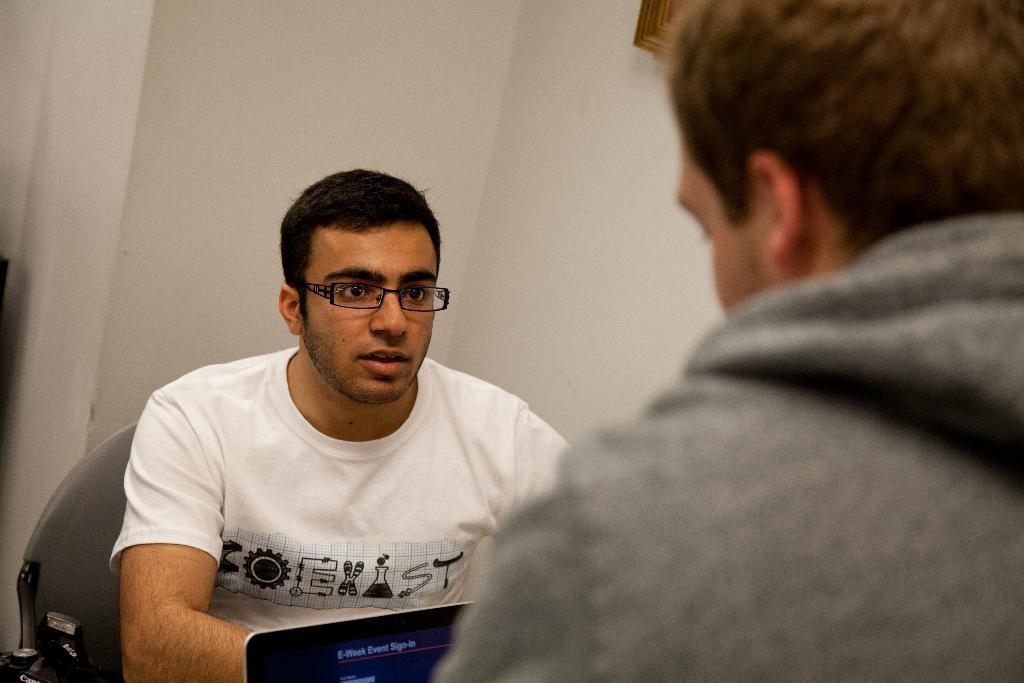In one or two sentences, can you explain what this image depicts? In this image I can see a person on the right. There is a laptop and a person is sitting, wearing a white t shirt and spectacles. There is a white wall at the back and there is a photo frame at the top. 